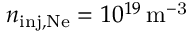Convert formula to latex. <formula><loc_0><loc_0><loc_500><loc_500>n _ { i n j , N e } = 1 0 ^ { 1 9 } \, m ^ { - 3 }</formula> 